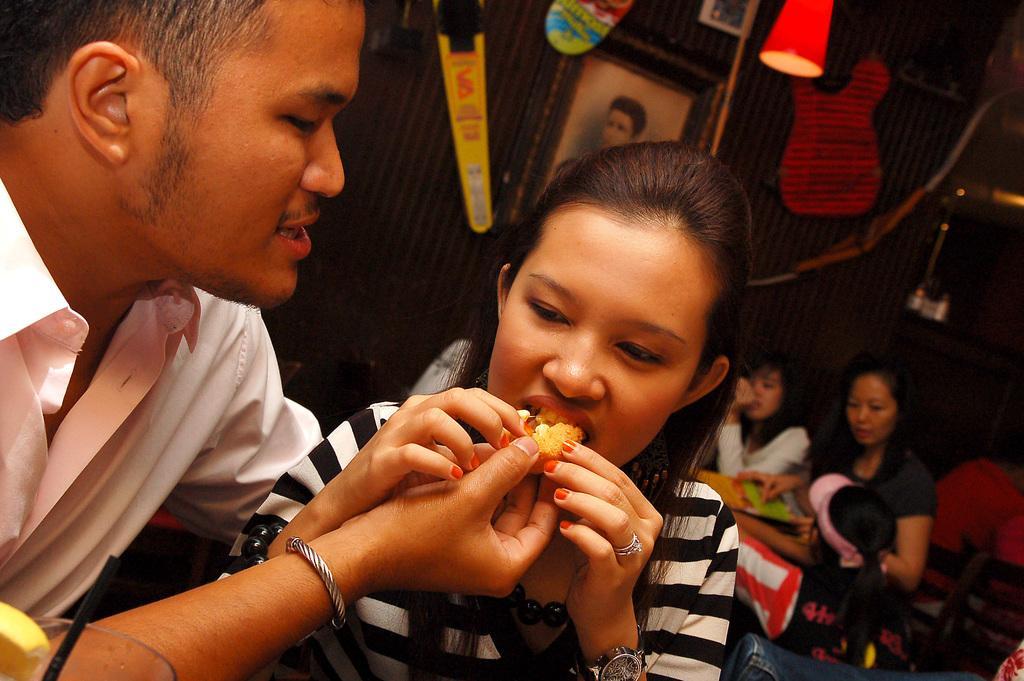Can you describe this image briefly? In this image in the foreground I can see man and woman, behind them there may be the wall, on which there is a photo frame, at the top there are some lights and objects, on the right side there are three women and chair, some other objects visible. 